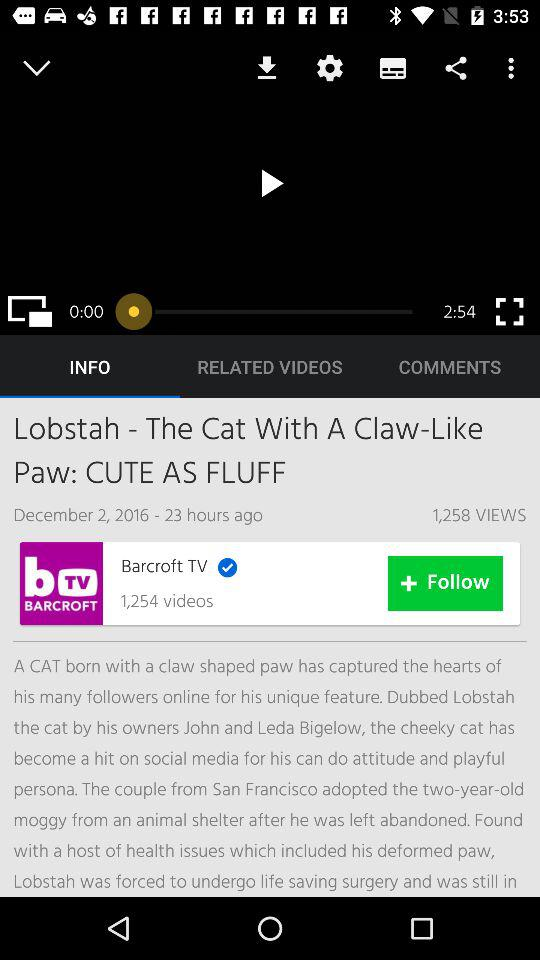What is the total duration of the video played on the screen? The total duration is 2 minutes and 54 seconds. 